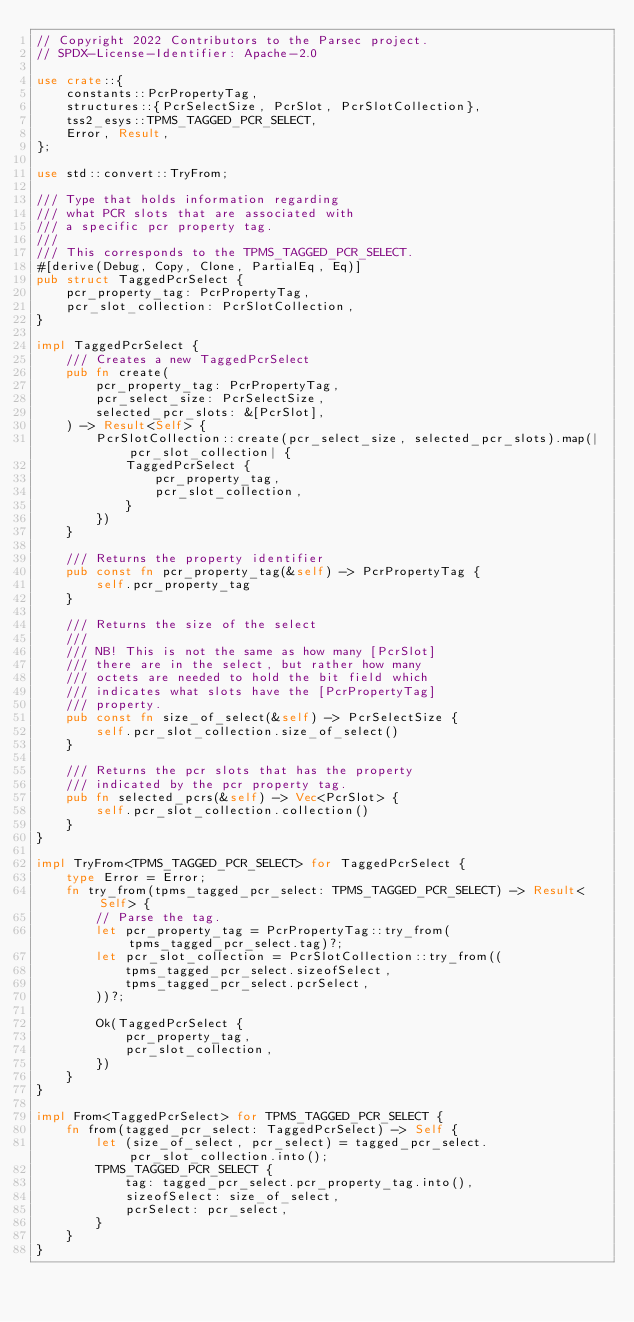Convert code to text. <code><loc_0><loc_0><loc_500><loc_500><_Rust_>// Copyright 2022 Contributors to the Parsec project.
// SPDX-License-Identifier: Apache-2.0

use crate::{
    constants::PcrPropertyTag,
    structures::{PcrSelectSize, PcrSlot, PcrSlotCollection},
    tss2_esys::TPMS_TAGGED_PCR_SELECT,
    Error, Result,
};

use std::convert::TryFrom;

/// Type that holds information regarding
/// what PCR slots that are associated with
/// a specific pcr property tag.
///
/// This corresponds to the TPMS_TAGGED_PCR_SELECT.
#[derive(Debug, Copy, Clone, PartialEq, Eq)]
pub struct TaggedPcrSelect {
    pcr_property_tag: PcrPropertyTag,
    pcr_slot_collection: PcrSlotCollection,
}

impl TaggedPcrSelect {
    /// Creates a new TaggedPcrSelect
    pub fn create(
        pcr_property_tag: PcrPropertyTag,
        pcr_select_size: PcrSelectSize,
        selected_pcr_slots: &[PcrSlot],
    ) -> Result<Self> {
        PcrSlotCollection::create(pcr_select_size, selected_pcr_slots).map(|pcr_slot_collection| {
            TaggedPcrSelect {
                pcr_property_tag,
                pcr_slot_collection,
            }
        })
    }

    /// Returns the property identifier
    pub const fn pcr_property_tag(&self) -> PcrPropertyTag {
        self.pcr_property_tag
    }

    /// Returns the size of the select
    ///
    /// NB! This is not the same as how many [PcrSlot]
    /// there are in the select, but rather how many
    /// octets are needed to hold the bit field which
    /// indicates what slots have the [PcrPropertyTag]
    /// property.
    pub const fn size_of_select(&self) -> PcrSelectSize {
        self.pcr_slot_collection.size_of_select()
    }

    /// Returns the pcr slots that has the property
    /// indicated by the pcr property tag.
    pub fn selected_pcrs(&self) -> Vec<PcrSlot> {
        self.pcr_slot_collection.collection()
    }
}

impl TryFrom<TPMS_TAGGED_PCR_SELECT> for TaggedPcrSelect {
    type Error = Error;
    fn try_from(tpms_tagged_pcr_select: TPMS_TAGGED_PCR_SELECT) -> Result<Self> {
        // Parse the tag.
        let pcr_property_tag = PcrPropertyTag::try_from(tpms_tagged_pcr_select.tag)?;
        let pcr_slot_collection = PcrSlotCollection::try_from((
            tpms_tagged_pcr_select.sizeofSelect,
            tpms_tagged_pcr_select.pcrSelect,
        ))?;

        Ok(TaggedPcrSelect {
            pcr_property_tag,
            pcr_slot_collection,
        })
    }
}

impl From<TaggedPcrSelect> for TPMS_TAGGED_PCR_SELECT {
    fn from(tagged_pcr_select: TaggedPcrSelect) -> Self {
        let (size_of_select, pcr_select) = tagged_pcr_select.pcr_slot_collection.into();
        TPMS_TAGGED_PCR_SELECT {
            tag: tagged_pcr_select.pcr_property_tag.into(),
            sizeofSelect: size_of_select,
            pcrSelect: pcr_select,
        }
    }
}
</code> 